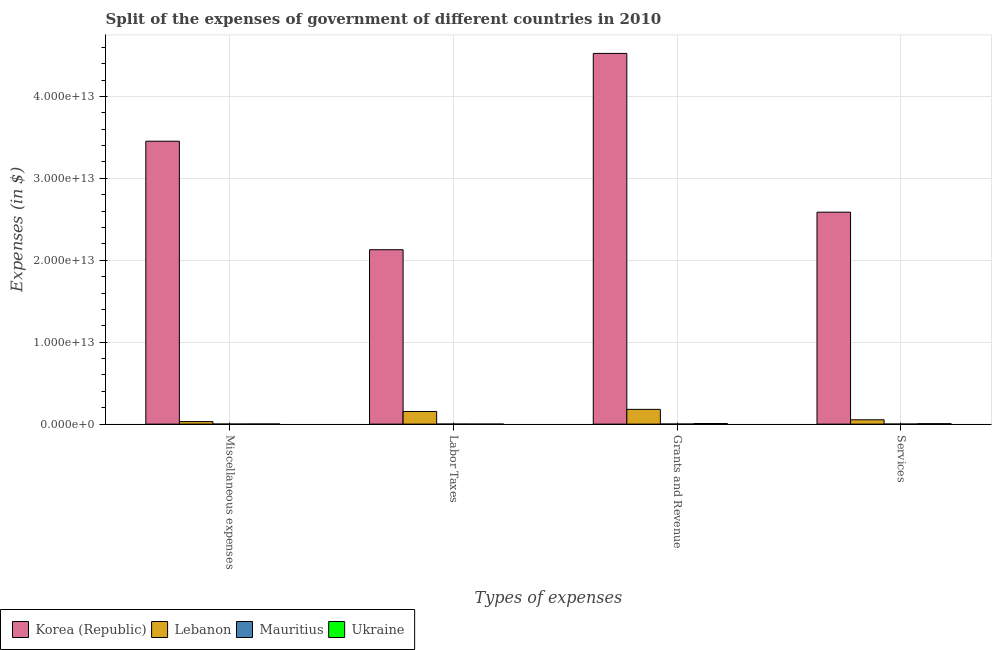How many groups of bars are there?
Your answer should be compact. 4. Are the number of bars per tick equal to the number of legend labels?
Your response must be concise. Yes. How many bars are there on the 1st tick from the left?
Provide a short and direct response. 4. How many bars are there on the 1st tick from the right?
Provide a succinct answer. 4. What is the label of the 2nd group of bars from the left?
Provide a short and direct response. Labor Taxes. What is the amount spent on grants and revenue in Lebanon?
Give a very brief answer. 1.80e+12. Across all countries, what is the maximum amount spent on miscellaneous expenses?
Provide a short and direct response. 3.45e+13. Across all countries, what is the minimum amount spent on grants and revenue?
Your answer should be compact. 9.53e+09. In which country was the amount spent on labor taxes minimum?
Keep it short and to the point. Ukraine. What is the total amount spent on miscellaneous expenses in the graph?
Offer a terse response. 3.49e+13. What is the difference between the amount spent on grants and revenue in Mauritius and that in Korea (Republic)?
Your response must be concise. -4.52e+13. What is the difference between the amount spent on miscellaneous expenses in Lebanon and the amount spent on grants and revenue in Korea (Republic)?
Ensure brevity in your answer.  -4.49e+13. What is the average amount spent on labor taxes per country?
Provide a succinct answer. 5.71e+12. What is the difference between the amount spent on labor taxes and amount spent on miscellaneous expenses in Lebanon?
Keep it short and to the point. 1.23e+12. What is the ratio of the amount spent on grants and revenue in Mauritius to that in Korea (Republic)?
Give a very brief answer. 0. Is the difference between the amount spent on labor taxes in Mauritius and Ukraine greater than the difference between the amount spent on services in Mauritius and Ukraine?
Provide a short and direct response. Yes. What is the difference between the highest and the second highest amount spent on services?
Keep it short and to the point. 2.53e+13. What is the difference between the highest and the lowest amount spent on miscellaneous expenses?
Offer a terse response. 3.45e+13. In how many countries, is the amount spent on grants and revenue greater than the average amount spent on grants and revenue taken over all countries?
Offer a very short reply. 1. Is it the case that in every country, the sum of the amount spent on miscellaneous expenses and amount spent on labor taxes is greater than the sum of amount spent on grants and revenue and amount spent on services?
Provide a short and direct response. No. What does the 4th bar from the left in Services represents?
Offer a terse response. Ukraine. What does the 2nd bar from the right in Services represents?
Offer a terse response. Mauritius. How many bars are there?
Keep it short and to the point. 16. What is the difference between two consecutive major ticks on the Y-axis?
Your response must be concise. 1.00e+13. Where does the legend appear in the graph?
Your response must be concise. Bottom left. How are the legend labels stacked?
Give a very brief answer. Horizontal. What is the title of the graph?
Make the answer very short. Split of the expenses of government of different countries in 2010. What is the label or title of the X-axis?
Make the answer very short. Types of expenses. What is the label or title of the Y-axis?
Keep it short and to the point. Expenses (in $). What is the Expenses (in $) in Korea (Republic) in Miscellaneous expenses?
Keep it short and to the point. 3.45e+13. What is the Expenses (in $) in Lebanon in Miscellaneous expenses?
Provide a short and direct response. 3.11e+11. What is the Expenses (in $) of Mauritius in Miscellaneous expenses?
Give a very brief answer. 7.10e+09. What is the Expenses (in $) of Ukraine in Miscellaneous expenses?
Give a very brief answer. 1.56e+1. What is the Expenses (in $) in Korea (Republic) in Labor Taxes?
Your answer should be very brief. 2.13e+13. What is the Expenses (in $) of Lebanon in Labor Taxes?
Provide a succinct answer. 1.54e+12. What is the Expenses (in $) in Mauritius in Labor Taxes?
Your answer should be very brief. 5.25e+09. What is the Expenses (in $) in Ukraine in Labor Taxes?
Ensure brevity in your answer.  1.08e+06. What is the Expenses (in $) of Korea (Republic) in Grants and Revenue?
Make the answer very short. 4.52e+13. What is the Expenses (in $) in Lebanon in Grants and Revenue?
Your answer should be very brief. 1.80e+12. What is the Expenses (in $) of Mauritius in Grants and Revenue?
Offer a terse response. 9.53e+09. What is the Expenses (in $) of Ukraine in Grants and Revenue?
Keep it short and to the point. 7.40e+1. What is the Expenses (in $) in Korea (Republic) in Services?
Ensure brevity in your answer.  2.59e+13. What is the Expenses (in $) of Lebanon in Services?
Give a very brief answer. 5.28e+11. What is the Expenses (in $) of Mauritius in Services?
Your answer should be compact. 8.07e+09. What is the Expenses (in $) in Ukraine in Services?
Your answer should be compact. 5.07e+1. Across all Types of expenses, what is the maximum Expenses (in $) of Korea (Republic)?
Provide a short and direct response. 4.52e+13. Across all Types of expenses, what is the maximum Expenses (in $) of Lebanon?
Make the answer very short. 1.80e+12. Across all Types of expenses, what is the maximum Expenses (in $) in Mauritius?
Give a very brief answer. 9.53e+09. Across all Types of expenses, what is the maximum Expenses (in $) of Ukraine?
Keep it short and to the point. 7.40e+1. Across all Types of expenses, what is the minimum Expenses (in $) in Korea (Republic)?
Provide a short and direct response. 2.13e+13. Across all Types of expenses, what is the minimum Expenses (in $) in Lebanon?
Offer a terse response. 3.11e+11. Across all Types of expenses, what is the minimum Expenses (in $) in Mauritius?
Offer a terse response. 5.25e+09. Across all Types of expenses, what is the minimum Expenses (in $) in Ukraine?
Provide a succinct answer. 1.08e+06. What is the total Expenses (in $) in Korea (Republic) in the graph?
Give a very brief answer. 1.27e+14. What is the total Expenses (in $) in Lebanon in the graph?
Keep it short and to the point. 4.18e+12. What is the total Expenses (in $) in Mauritius in the graph?
Keep it short and to the point. 2.99e+1. What is the total Expenses (in $) in Ukraine in the graph?
Make the answer very short. 1.40e+11. What is the difference between the Expenses (in $) of Korea (Republic) in Miscellaneous expenses and that in Labor Taxes?
Keep it short and to the point. 1.32e+13. What is the difference between the Expenses (in $) in Lebanon in Miscellaneous expenses and that in Labor Taxes?
Ensure brevity in your answer.  -1.23e+12. What is the difference between the Expenses (in $) of Mauritius in Miscellaneous expenses and that in Labor Taxes?
Provide a short and direct response. 1.85e+09. What is the difference between the Expenses (in $) of Ukraine in Miscellaneous expenses and that in Labor Taxes?
Your answer should be very brief. 1.56e+1. What is the difference between the Expenses (in $) in Korea (Republic) in Miscellaneous expenses and that in Grants and Revenue?
Your answer should be compact. -1.07e+13. What is the difference between the Expenses (in $) in Lebanon in Miscellaneous expenses and that in Grants and Revenue?
Provide a short and direct response. -1.49e+12. What is the difference between the Expenses (in $) in Mauritius in Miscellaneous expenses and that in Grants and Revenue?
Your answer should be compact. -2.42e+09. What is the difference between the Expenses (in $) in Ukraine in Miscellaneous expenses and that in Grants and Revenue?
Give a very brief answer. -5.85e+1. What is the difference between the Expenses (in $) in Korea (Republic) in Miscellaneous expenses and that in Services?
Ensure brevity in your answer.  8.66e+12. What is the difference between the Expenses (in $) of Lebanon in Miscellaneous expenses and that in Services?
Offer a very short reply. -2.17e+11. What is the difference between the Expenses (in $) of Mauritius in Miscellaneous expenses and that in Services?
Offer a terse response. -9.65e+08. What is the difference between the Expenses (in $) of Ukraine in Miscellaneous expenses and that in Services?
Keep it short and to the point. -3.51e+1. What is the difference between the Expenses (in $) of Korea (Republic) in Labor Taxes and that in Grants and Revenue?
Ensure brevity in your answer.  -2.40e+13. What is the difference between the Expenses (in $) of Lebanon in Labor Taxes and that in Grants and Revenue?
Offer a very short reply. -2.58e+11. What is the difference between the Expenses (in $) in Mauritius in Labor Taxes and that in Grants and Revenue?
Provide a succinct answer. -4.28e+09. What is the difference between the Expenses (in $) of Ukraine in Labor Taxes and that in Grants and Revenue?
Keep it short and to the point. -7.40e+1. What is the difference between the Expenses (in $) of Korea (Republic) in Labor Taxes and that in Services?
Make the answer very short. -4.58e+12. What is the difference between the Expenses (in $) of Lebanon in Labor Taxes and that in Services?
Give a very brief answer. 1.01e+12. What is the difference between the Expenses (in $) in Mauritius in Labor Taxes and that in Services?
Make the answer very short. -2.82e+09. What is the difference between the Expenses (in $) in Ukraine in Labor Taxes and that in Services?
Make the answer very short. -5.07e+1. What is the difference between the Expenses (in $) of Korea (Republic) in Grants and Revenue and that in Services?
Give a very brief answer. 1.94e+13. What is the difference between the Expenses (in $) of Lebanon in Grants and Revenue and that in Services?
Offer a terse response. 1.27e+12. What is the difference between the Expenses (in $) of Mauritius in Grants and Revenue and that in Services?
Give a very brief answer. 1.46e+09. What is the difference between the Expenses (in $) in Ukraine in Grants and Revenue and that in Services?
Offer a very short reply. 2.34e+1. What is the difference between the Expenses (in $) of Korea (Republic) in Miscellaneous expenses and the Expenses (in $) of Lebanon in Labor Taxes?
Offer a terse response. 3.30e+13. What is the difference between the Expenses (in $) in Korea (Republic) in Miscellaneous expenses and the Expenses (in $) in Mauritius in Labor Taxes?
Give a very brief answer. 3.45e+13. What is the difference between the Expenses (in $) of Korea (Republic) in Miscellaneous expenses and the Expenses (in $) of Ukraine in Labor Taxes?
Your response must be concise. 3.45e+13. What is the difference between the Expenses (in $) of Lebanon in Miscellaneous expenses and the Expenses (in $) of Mauritius in Labor Taxes?
Offer a terse response. 3.06e+11. What is the difference between the Expenses (in $) in Lebanon in Miscellaneous expenses and the Expenses (in $) in Ukraine in Labor Taxes?
Your response must be concise. 3.11e+11. What is the difference between the Expenses (in $) in Mauritius in Miscellaneous expenses and the Expenses (in $) in Ukraine in Labor Taxes?
Ensure brevity in your answer.  7.10e+09. What is the difference between the Expenses (in $) in Korea (Republic) in Miscellaneous expenses and the Expenses (in $) in Lebanon in Grants and Revenue?
Keep it short and to the point. 3.27e+13. What is the difference between the Expenses (in $) in Korea (Republic) in Miscellaneous expenses and the Expenses (in $) in Mauritius in Grants and Revenue?
Your response must be concise. 3.45e+13. What is the difference between the Expenses (in $) of Korea (Republic) in Miscellaneous expenses and the Expenses (in $) of Ukraine in Grants and Revenue?
Your response must be concise. 3.45e+13. What is the difference between the Expenses (in $) in Lebanon in Miscellaneous expenses and the Expenses (in $) in Mauritius in Grants and Revenue?
Ensure brevity in your answer.  3.02e+11. What is the difference between the Expenses (in $) in Lebanon in Miscellaneous expenses and the Expenses (in $) in Ukraine in Grants and Revenue?
Your answer should be compact. 2.37e+11. What is the difference between the Expenses (in $) of Mauritius in Miscellaneous expenses and the Expenses (in $) of Ukraine in Grants and Revenue?
Make the answer very short. -6.69e+1. What is the difference between the Expenses (in $) in Korea (Republic) in Miscellaneous expenses and the Expenses (in $) in Lebanon in Services?
Give a very brief answer. 3.40e+13. What is the difference between the Expenses (in $) in Korea (Republic) in Miscellaneous expenses and the Expenses (in $) in Mauritius in Services?
Keep it short and to the point. 3.45e+13. What is the difference between the Expenses (in $) in Korea (Republic) in Miscellaneous expenses and the Expenses (in $) in Ukraine in Services?
Your answer should be compact. 3.45e+13. What is the difference between the Expenses (in $) in Lebanon in Miscellaneous expenses and the Expenses (in $) in Mauritius in Services?
Keep it short and to the point. 3.03e+11. What is the difference between the Expenses (in $) of Lebanon in Miscellaneous expenses and the Expenses (in $) of Ukraine in Services?
Keep it short and to the point. 2.60e+11. What is the difference between the Expenses (in $) of Mauritius in Miscellaneous expenses and the Expenses (in $) of Ukraine in Services?
Provide a short and direct response. -4.36e+1. What is the difference between the Expenses (in $) of Korea (Republic) in Labor Taxes and the Expenses (in $) of Lebanon in Grants and Revenue?
Make the answer very short. 1.95e+13. What is the difference between the Expenses (in $) of Korea (Republic) in Labor Taxes and the Expenses (in $) of Mauritius in Grants and Revenue?
Your response must be concise. 2.13e+13. What is the difference between the Expenses (in $) in Korea (Republic) in Labor Taxes and the Expenses (in $) in Ukraine in Grants and Revenue?
Make the answer very short. 2.12e+13. What is the difference between the Expenses (in $) in Lebanon in Labor Taxes and the Expenses (in $) in Mauritius in Grants and Revenue?
Keep it short and to the point. 1.53e+12. What is the difference between the Expenses (in $) of Lebanon in Labor Taxes and the Expenses (in $) of Ukraine in Grants and Revenue?
Give a very brief answer. 1.47e+12. What is the difference between the Expenses (in $) in Mauritius in Labor Taxes and the Expenses (in $) in Ukraine in Grants and Revenue?
Provide a succinct answer. -6.88e+1. What is the difference between the Expenses (in $) of Korea (Republic) in Labor Taxes and the Expenses (in $) of Lebanon in Services?
Provide a short and direct response. 2.08e+13. What is the difference between the Expenses (in $) of Korea (Republic) in Labor Taxes and the Expenses (in $) of Mauritius in Services?
Offer a very short reply. 2.13e+13. What is the difference between the Expenses (in $) in Korea (Republic) in Labor Taxes and the Expenses (in $) in Ukraine in Services?
Offer a terse response. 2.12e+13. What is the difference between the Expenses (in $) of Lebanon in Labor Taxes and the Expenses (in $) of Mauritius in Services?
Provide a succinct answer. 1.53e+12. What is the difference between the Expenses (in $) in Lebanon in Labor Taxes and the Expenses (in $) in Ukraine in Services?
Your answer should be very brief. 1.49e+12. What is the difference between the Expenses (in $) in Mauritius in Labor Taxes and the Expenses (in $) in Ukraine in Services?
Make the answer very short. -4.54e+1. What is the difference between the Expenses (in $) of Korea (Republic) in Grants and Revenue and the Expenses (in $) of Lebanon in Services?
Offer a very short reply. 4.47e+13. What is the difference between the Expenses (in $) of Korea (Republic) in Grants and Revenue and the Expenses (in $) of Mauritius in Services?
Make the answer very short. 4.52e+13. What is the difference between the Expenses (in $) of Korea (Republic) in Grants and Revenue and the Expenses (in $) of Ukraine in Services?
Provide a succinct answer. 4.52e+13. What is the difference between the Expenses (in $) of Lebanon in Grants and Revenue and the Expenses (in $) of Mauritius in Services?
Your response must be concise. 1.79e+12. What is the difference between the Expenses (in $) of Lebanon in Grants and Revenue and the Expenses (in $) of Ukraine in Services?
Ensure brevity in your answer.  1.75e+12. What is the difference between the Expenses (in $) in Mauritius in Grants and Revenue and the Expenses (in $) in Ukraine in Services?
Ensure brevity in your answer.  -4.12e+1. What is the average Expenses (in $) of Korea (Republic) per Types of expenses?
Your answer should be very brief. 3.17e+13. What is the average Expenses (in $) in Lebanon per Types of expenses?
Give a very brief answer. 1.04e+12. What is the average Expenses (in $) of Mauritius per Types of expenses?
Your answer should be very brief. 7.49e+09. What is the average Expenses (in $) in Ukraine per Types of expenses?
Your response must be concise. 3.51e+1. What is the difference between the Expenses (in $) of Korea (Republic) and Expenses (in $) of Lebanon in Miscellaneous expenses?
Your answer should be very brief. 3.42e+13. What is the difference between the Expenses (in $) of Korea (Republic) and Expenses (in $) of Mauritius in Miscellaneous expenses?
Your response must be concise. 3.45e+13. What is the difference between the Expenses (in $) of Korea (Republic) and Expenses (in $) of Ukraine in Miscellaneous expenses?
Make the answer very short. 3.45e+13. What is the difference between the Expenses (in $) of Lebanon and Expenses (in $) of Mauritius in Miscellaneous expenses?
Keep it short and to the point. 3.04e+11. What is the difference between the Expenses (in $) of Lebanon and Expenses (in $) of Ukraine in Miscellaneous expenses?
Provide a succinct answer. 2.96e+11. What is the difference between the Expenses (in $) of Mauritius and Expenses (in $) of Ukraine in Miscellaneous expenses?
Offer a very short reply. -8.48e+09. What is the difference between the Expenses (in $) of Korea (Republic) and Expenses (in $) of Lebanon in Labor Taxes?
Keep it short and to the point. 1.97e+13. What is the difference between the Expenses (in $) of Korea (Republic) and Expenses (in $) of Mauritius in Labor Taxes?
Provide a short and direct response. 2.13e+13. What is the difference between the Expenses (in $) of Korea (Republic) and Expenses (in $) of Ukraine in Labor Taxes?
Offer a very short reply. 2.13e+13. What is the difference between the Expenses (in $) of Lebanon and Expenses (in $) of Mauritius in Labor Taxes?
Offer a terse response. 1.54e+12. What is the difference between the Expenses (in $) in Lebanon and Expenses (in $) in Ukraine in Labor Taxes?
Offer a terse response. 1.54e+12. What is the difference between the Expenses (in $) of Mauritius and Expenses (in $) of Ukraine in Labor Taxes?
Your response must be concise. 5.25e+09. What is the difference between the Expenses (in $) in Korea (Republic) and Expenses (in $) in Lebanon in Grants and Revenue?
Offer a terse response. 4.34e+13. What is the difference between the Expenses (in $) in Korea (Republic) and Expenses (in $) in Mauritius in Grants and Revenue?
Your response must be concise. 4.52e+13. What is the difference between the Expenses (in $) of Korea (Republic) and Expenses (in $) of Ukraine in Grants and Revenue?
Offer a terse response. 4.52e+13. What is the difference between the Expenses (in $) of Lebanon and Expenses (in $) of Mauritius in Grants and Revenue?
Provide a short and direct response. 1.79e+12. What is the difference between the Expenses (in $) of Lebanon and Expenses (in $) of Ukraine in Grants and Revenue?
Give a very brief answer. 1.73e+12. What is the difference between the Expenses (in $) of Mauritius and Expenses (in $) of Ukraine in Grants and Revenue?
Provide a short and direct response. -6.45e+1. What is the difference between the Expenses (in $) of Korea (Republic) and Expenses (in $) of Lebanon in Services?
Your response must be concise. 2.53e+13. What is the difference between the Expenses (in $) of Korea (Republic) and Expenses (in $) of Mauritius in Services?
Give a very brief answer. 2.59e+13. What is the difference between the Expenses (in $) of Korea (Republic) and Expenses (in $) of Ukraine in Services?
Your answer should be compact. 2.58e+13. What is the difference between the Expenses (in $) of Lebanon and Expenses (in $) of Mauritius in Services?
Make the answer very short. 5.20e+11. What is the difference between the Expenses (in $) of Lebanon and Expenses (in $) of Ukraine in Services?
Your answer should be compact. 4.77e+11. What is the difference between the Expenses (in $) of Mauritius and Expenses (in $) of Ukraine in Services?
Give a very brief answer. -4.26e+1. What is the ratio of the Expenses (in $) in Korea (Republic) in Miscellaneous expenses to that in Labor Taxes?
Your response must be concise. 1.62. What is the ratio of the Expenses (in $) in Lebanon in Miscellaneous expenses to that in Labor Taxes?
Your response must be concise. 0.2. What is the ratio of the Expenses (in $) in Mauritius in Miscellaneous expenses to that in Labor Taxes?
Offer a very short reply. 1.35. What is the ratio of the Expenses (in $) of Ukraine in Miscellaneous expenses to that in Labor Taxes?
Ensure brevity in your answer.  1.44e+04. What is the ratio of the Expenses (in $) in Korea (Republic) in Miscellaneous expenses to that in Grants and Revenue?
Keep it short and to the point. 0.76. What is the ratio of the Expenses (in $) in Lebanon in Miscellaneous expenses to that in Grants and Revenue?
Provide a short and direct response. 0.17. What is the ratio of the Expenses (in $) of Mauritius in Miscellaneous expenses to that in Grants and Revenue?
Ensure brevity in your answer.  0.75. What is the ratio of the Expenses (in $) of Ukraine in Miscellaneous expenses to that in Grants and Revenue?
Give a very brief answer. 0.21. What is the ratio of the Expenses (in $) in Korea (Republic) in Miscellaneous expenses to that in Services?
Your answer should be very brief. 1.33. What is the ratio of the Expenses (in $) of Lebanon in Miscellaneous expenses to that in Services?
Provide a succinct answer. 0.59. What is the ratio of the Expenses (in $) of Mauritius in Miscellaneous expenses to that in Services?
Your answer should be compact. 0.88. What is the ratio of the Expenses (in $) in Ukraine in Miscellaneous expenses to that in Services?
Make the answer very short. 0.31. What is the ratio of the Expenses (in $) in Korea (Republic) in Labor Taxes to that in Grants and Revenue?
Make the answer very short. 0.47. What is the ratio of the Expenses (in $) in Lebanon in Labor Taxes to that in Grants and Revenue?
Make the answer very short. 0.86. What is the ratio of the Expenses (in $) of Mauritius in Labor Taxes to that in Grants and Revenue?
Keep it short and to the point. 0.55. What is the ratio of the Expenses (in $) in Ukraine in Labor Taxes to that in Grants and Revenue?
Give a very brief answer. 0. What is the ratio of the Expenses (in $) in Korea (Republic) in Labor Taxes to that in Services?
Your answer should be very brief. 0.82. What is the ratio of the Expenses (in $) of Lebanon in Labor Taxes to that in Services?
Provide a succinct answer. 2.92. What is the ratio of the Expenses (in $) of Mauritius in Labor Taxes to that in Services?
Make the answer very short. 0.65. What is the ratio of the Expenses (in $) of Korea (Republic) in Grants and Revenue to that in Services?
Provide a succinct answer. 1.75. What is the ratio of the Expenses (in $) in Lebanon in Grants and Revenue to that in Services?
Your answer should be very brief. 3.41. What is the ratio of the Expenses (in $) in Mauritius in Grants and Revenue to that in Services?
Offer a very short reply. 1.18. What is the ratio of the Expenses (in $) in Ukraine in Grants and Revenue to that in Services?
Your answer should be very brief. 1.46. What is the difference between the highest and the second highest Expenses (in $) in Korea (Republic)?
Keep it short and to the point. 1.07e+13. What is the difference between the highest and the second highest Expenses (in $) of Lebanon?
Offer a very short reply. 2.58e+11. What is the difference between the highest and the second highest Expenses (in $) in Mauritius?
Provide a short and direct response. 1.46e+09. What is the difference between the highest and the second highest Expenses (in $) in Ukraine?
Make the answer very short. 2.34e+1. What is the difference between the highest and the lowest Expenses (in $) of Korea (Republic)?
Your response must be concise. 2.40e+13. What is the difference between the highest and the lowest Expenses (in $) in Lebanon?
Make the answer very short. 1.49e+12. What is the difference between the highest and the lowest Expenses (in $) of Mauritius?
Make the answer very short. 4.28e+09. What is the difference between the highest and the lowest Expenses (in $) of Ukraine?
Ensure brevity in your answer.  7.40e+1. 